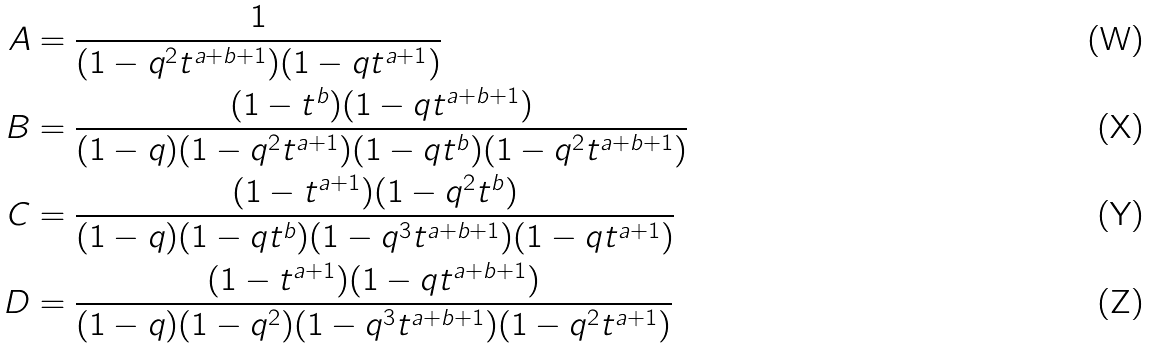Convert formula to latex. <formula><loc_0><loc_0><loc_500><loc_500>A & = \frac { 1 } { ( 1 - q ^ { 2 } t ^ { a + b + 1 } ) ( 1 - q t ^ { a + 1 } ) } \\ B & = \frac { ( 1 - t ^ { b } ) ( 1 - q t ^ { a + b + 1 } ) } { ( 1 - q ) ( 1 - q ^ { 2 } t ^ { a + 1 } ) ( 1 - q t ^ { b } ) ( 1 - q ^ { 2 } t ^ { a + b + 1 } ) } \\ C & = \frac { ( 1 - t ^ { a + 1 } ) ( 1 - q ^ { 2 } t ^ { b } ) } { ( 1 - q ) ( 1 - q t ^ { b } ) ( 1 - q ^ { 3 } t ^ { a + b + 1 } ) ( 1 - q t ^ { a + 1 } ) } \\ D & = \frac { ( 1 - t ^ { a + 1 } ) ( 1 - q t ^ { a + b + 1 } ) } { ( 1 - q ) ( 1 - q ^ { 2 } ) ( 1 - q ^ { 3 } t ^ { a + b + 1 } ) ( 1 - q ^ { 2 } t ^ { a + 1 } ) }</formula> 